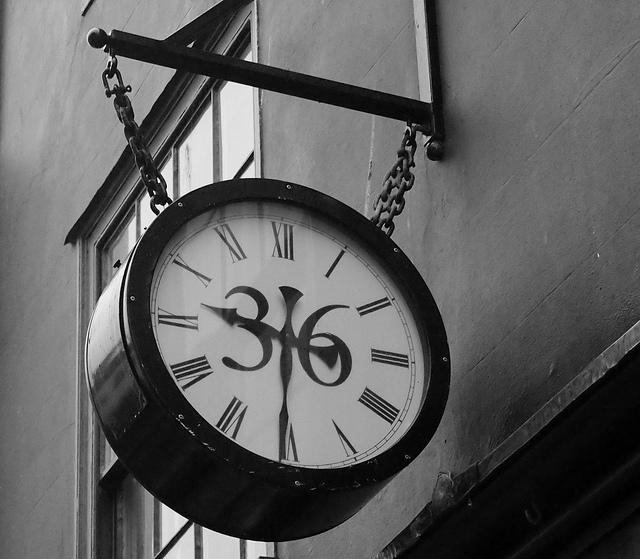Is this indoors?
Give a very brief answer. No. What holds the clock up?
Answer briefly. Chains. What time is it in this picture?
Answer briefly. 9:30. 